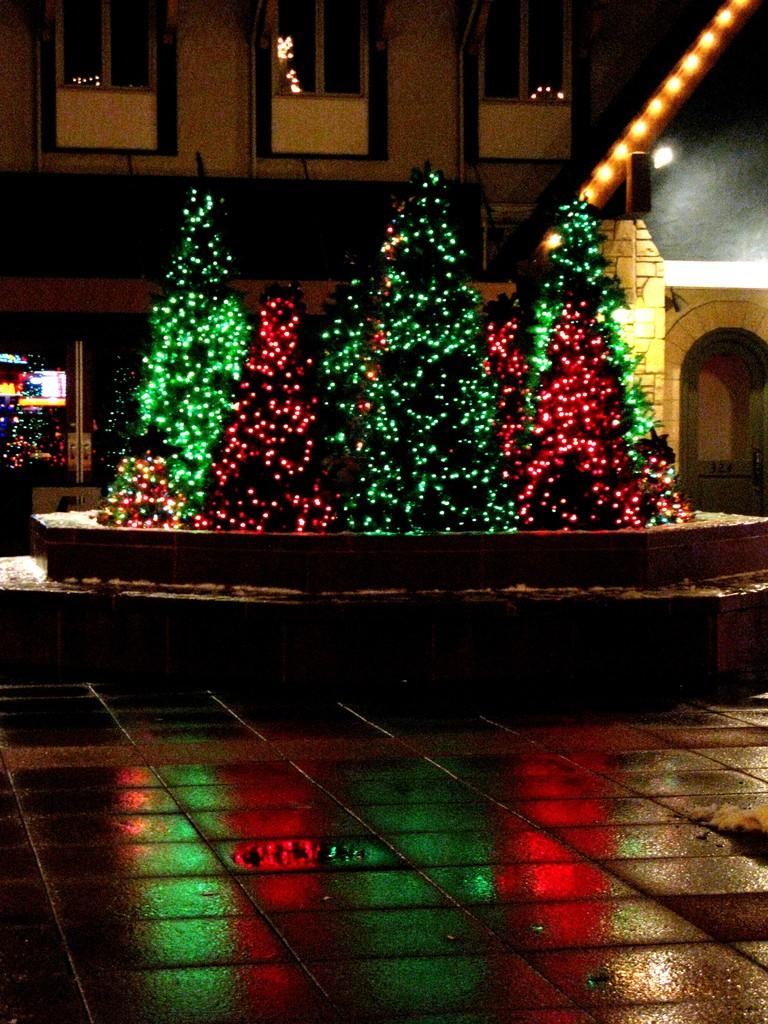What type of lighting is present in the image? There are decorative lights in the image. What type of natural elements can be seen in the image? There are trees in the image. What type of architectural feature is present in the image? There are glass windows in the image. How far away is the meal from the decorative lights in the image? There is no meal present in the image. 